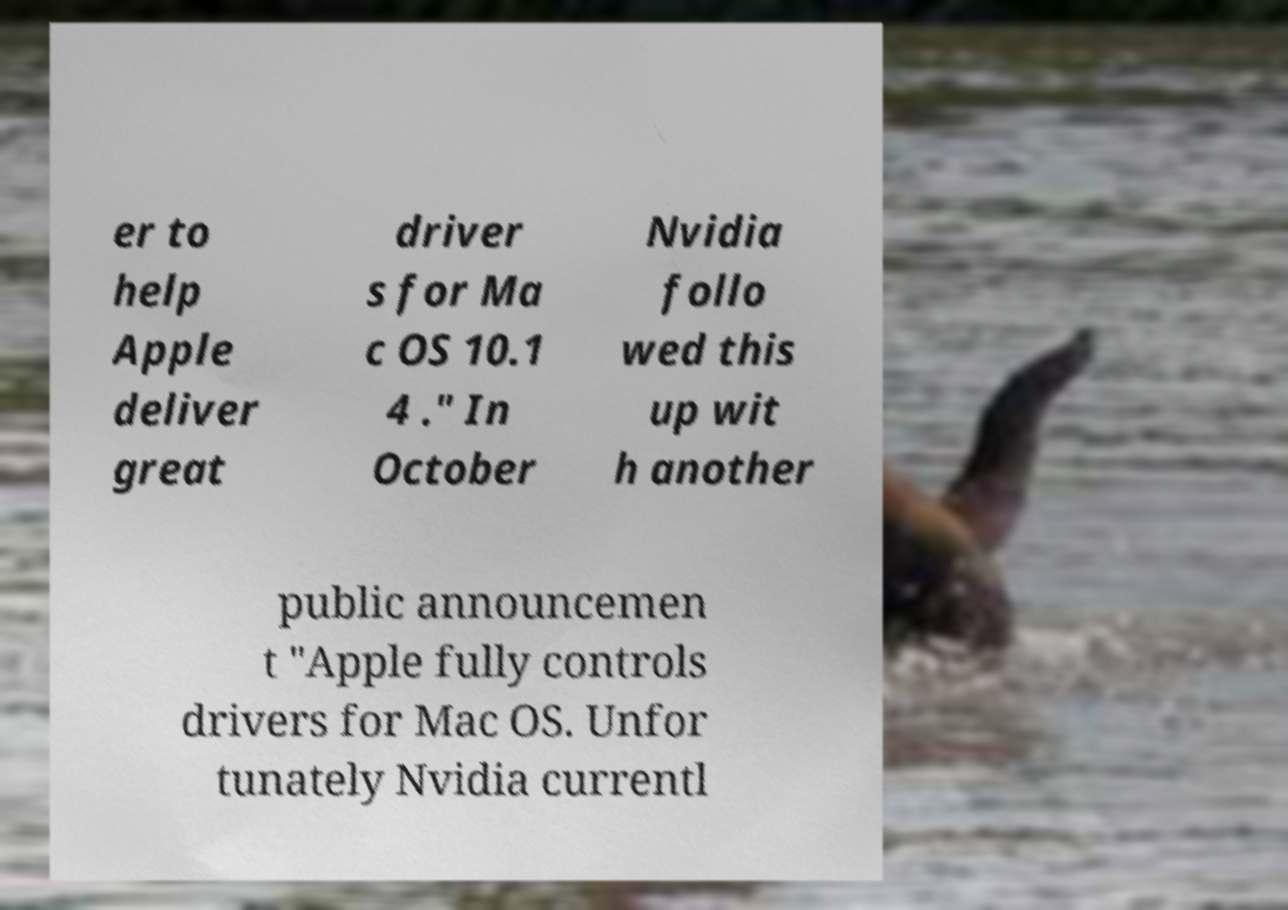Please read and relay the text visible in this image. What does it say? er to help Apple deliver great driver s for Ma c OS 10.1 4 ." In October Nvidia follo wed this up wit h another public announcemen t "Apple fully controls drivers for Mac OS. Unfor tunately Nvidia currentl 